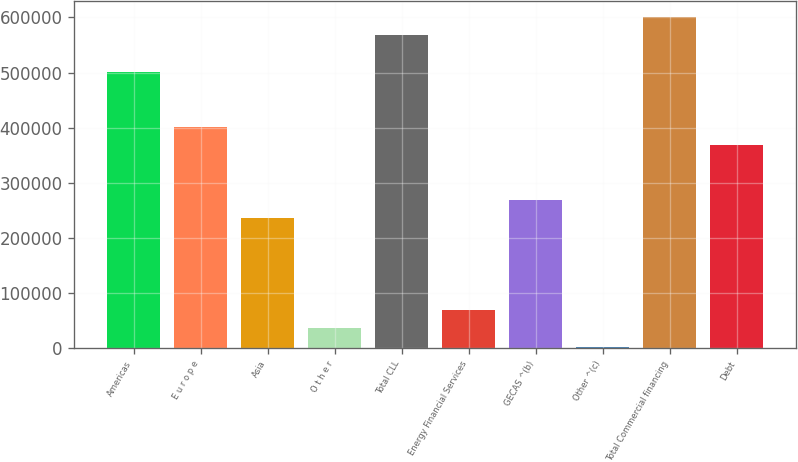<chart> <loc_0><loc_0><loc_500><loc_500><bar_chart><fcel>Americas<fcel>E u r o p e<fcel>Asia<fcel>O t h e r<fcel>Total CLL<fcel>Energy Financial Services<fcel>GECAS ^(b)<fcel>Other ^(c)<fcel>Total Commercial financing<fcel>Debt<nl><fcel>500888<fcel>401234<fcel>235142<fcel>35832.3<fcel>567325<fcel>69050.6<fcel>268360<fcel>2614<fcel>600543<fcel>368015<nl></chart> 